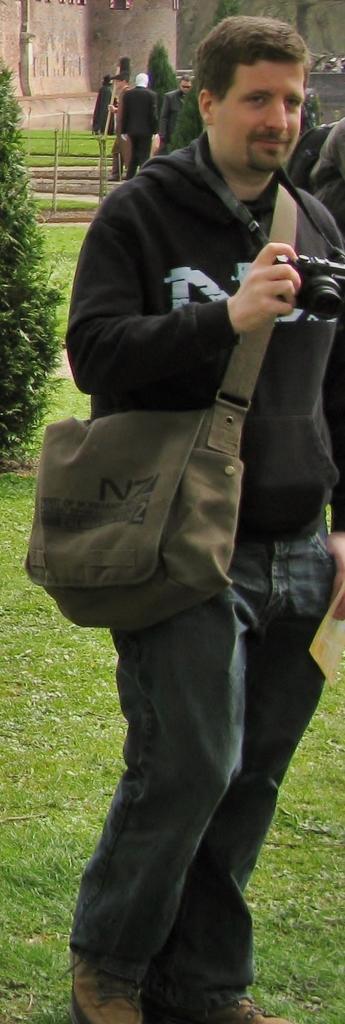In one or two sentences, can you explain what this image depicts? this picture shows a Man Standing and holding a camera in his hand and he wore a bag and we see a couple of trees and few people standing 